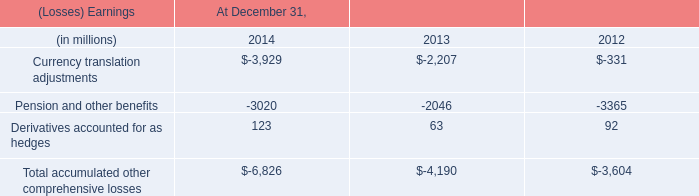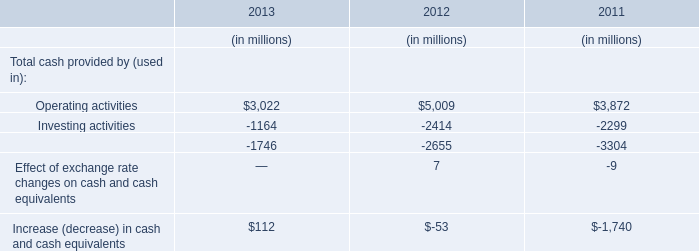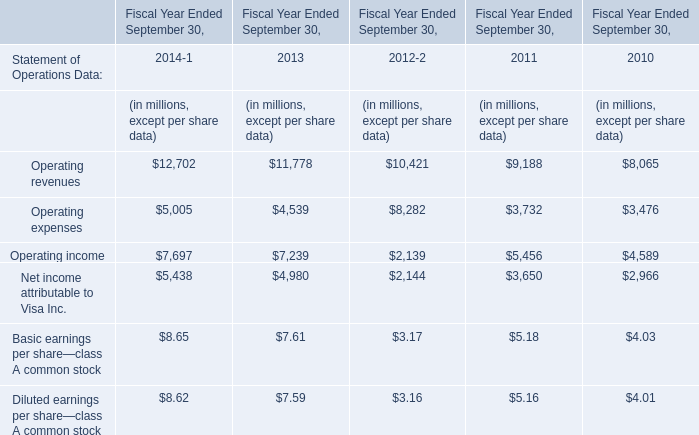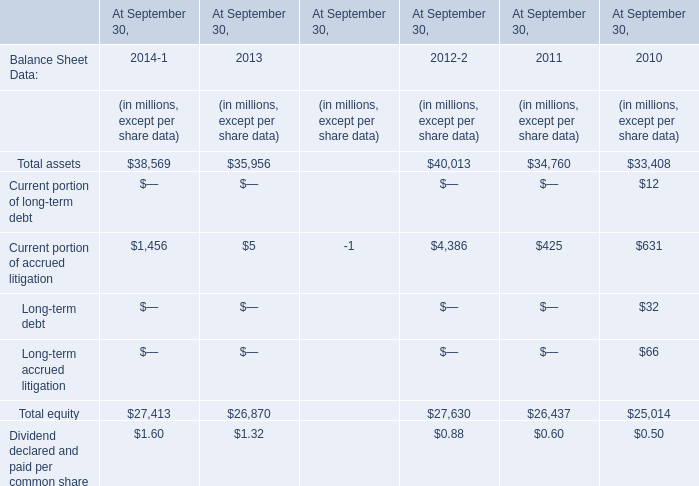If Operating income develops with the same growth rate in Fiscal Year Ended September 30,2014, what will it reach in Fiscal Year Ended September 30,2015? (in million) 
Computations: (7697 * (1 + ((7697 - 7239) / 7239)))
Answer: 8183.97693. 